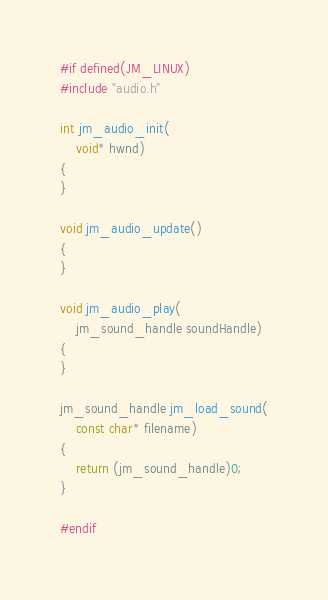Convert code to text. <code><loc_0><loc_0><loc_500><loc_500><_C_>#if defined(JM_LINUX)
#include "audio.h"

int jm_audio_init(
	void* hwnd)
{
}

void jm_audio_update()
{
}

void jm_audio_play(
	jm_sound_handle soundHandle)
{
}

jm_sound_handle jm_load_sound(
	const char* filename)
{
    return (jm_sound_handle)0;
}

#endif</code> 